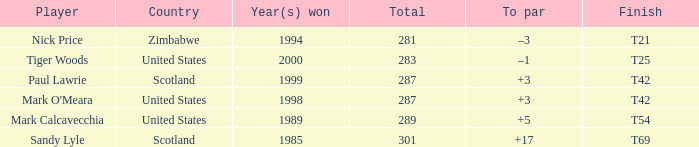What is Tiger Woods' to par? –1. 